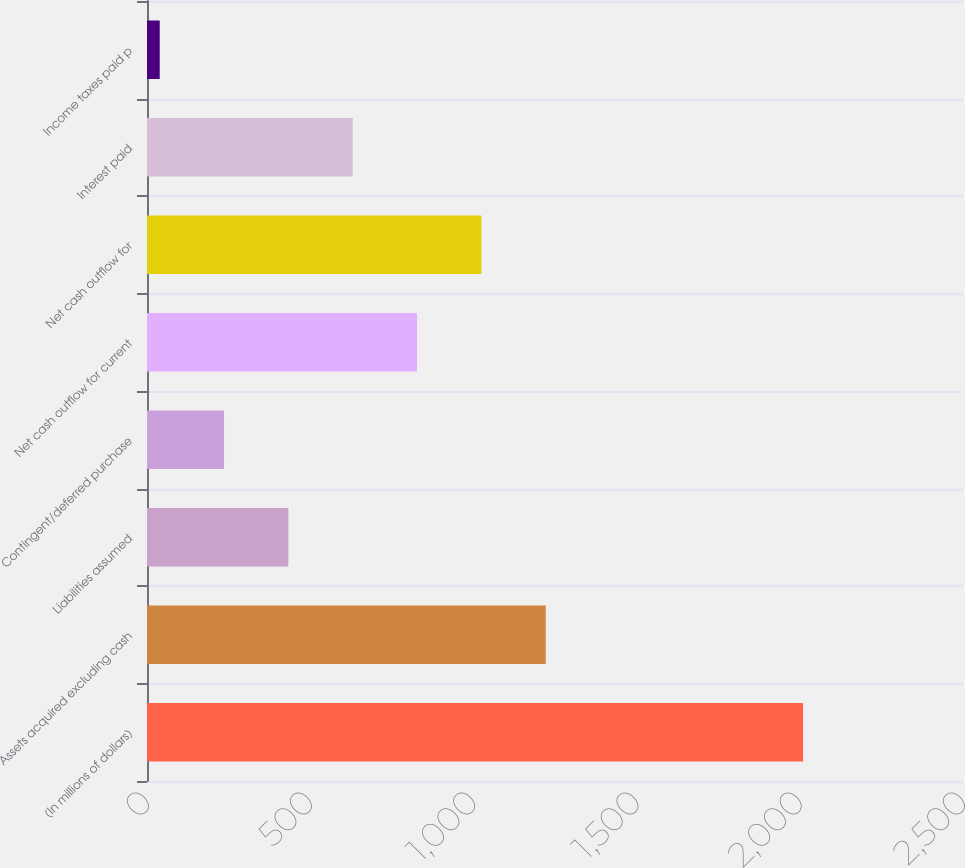Convert chart to OTSL. <chart><loc_0><loc_0><loc_500><loc_500><bar_chart><fcel>(In millions of dollars)<fcel>Assets acquired excluding cash<fcel>Liabilities assumed<fcel>Contingent/deferred purchase<fcel>Net cash outflow for current<fcel>Net cash outflow for<fcel>Interest paid<fcel>Income taxes paid p<nl><fcel>2010<fcel>1221.6<fcel>433.2<fcel>236.1<fcel>827.4<fcel>1024.5<fcel>630.3<fcel>39<nl></chart> 